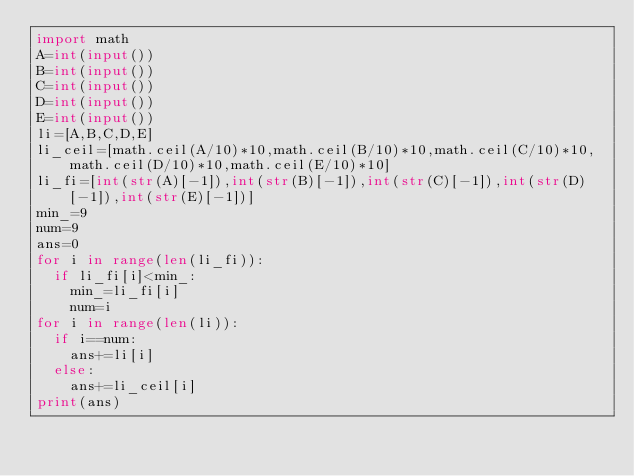Convert code to text. <code><loc_0><loc_0><loc_500><loc_500><_Python_>import math
A=int(input())
B=int(input())
C=int(input())
D=int(input())
E=int(input())
li=[A,B,C,D,E]
li_ceil=[math.ceil(A/10)*10,math.ceil(B/10)*10,math.ceil(C/10)*10,math.ceil(D/10)*10,math.ceil(E/10)*10]
li_fi=[int(str(A)[-1]),int(str(B)[-1]),int(str(C)[-1]),int(str(D)[-1]),int(str(E)[-1])]
min_=9
num=9
ans=0
for i in range(len(li_fi)):
  if li_fi[i]<min_:
    min_=li_fi[i]
    num=i
for i in range(len(li)):
  if i==num:
    ans+=li[i]
  else:
    ans+=li_ceil[i]
print(ans)</code> 